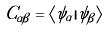<formula> <loc_0><loc_0><loc_500><loc_500>C _ { \alpha \beta } = \langle \psi _ { \alpha } | \psi _ { \beta } \rangle</formula> 